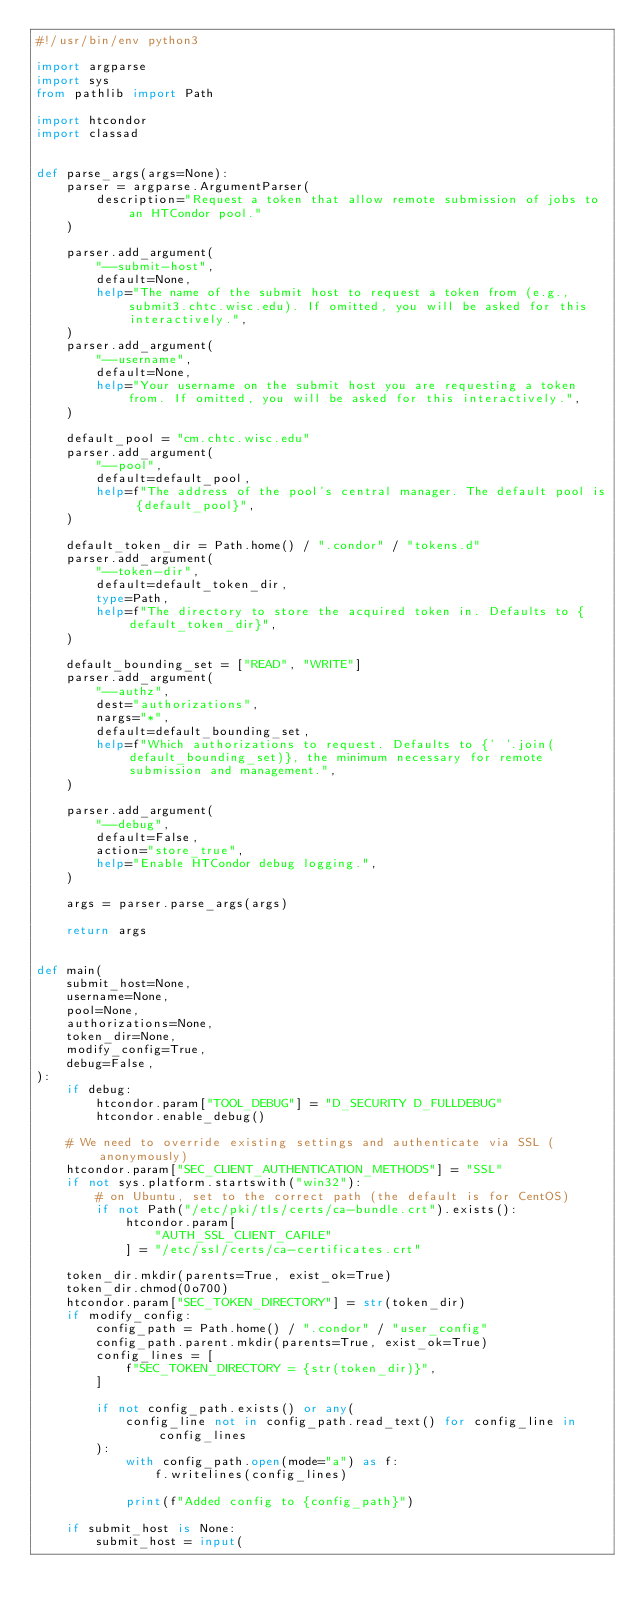Convert code to text. <code><loc_0><loc_0><loc_500><loc_500><_Python_>#!/usr/bin/env python3

import argparse
import sys
from pathlib import Path

import htcondor
import classad


def parse_args(args=None):
    parser = argparse.ArgumentParser(
        description="Request a token that allow remote submission of jobs to an HTCondor pool."
    )

    parser.add_argument(
        "--submit-host",
        default=None,
        help="The name of the submit host to request a token from (e.g., submit3.chtc.wisc.edu). If omitted, you will be asked for this interactively.",
    )
    parser.add_argument(
        "--username",
        default=None,
        help="Your username on the submit host you are requesting a token from. If omitted, you will be asked for this interactively.",
    )

    default_pool = "cm.chtc.wisc.edu"
    parser.add_argument(
        "--pool",
        default=default_pool,
        help=f"The address of the pool's central manager. The default pool is {default_pool}",
    )

    default_token_dir = Path.home() / ".condor" / "tokens.d"
    parser.add_argument(
        "--token-dir",
        default=default_token_dir,
        type=Path,
        help=f"The directory to store the acquired token in. Defaults to {default_token_dir}",
    )

    default_bounding_set = ["READ", "WRITE"]
    parser.add_argument(
        "--authz",
        dest="authorizations",
        nargs="*",
        default=default_bounding_set,
        help=f"Which authorizations to request. Defaults to {' '.join(default_bounding_set)}, the minimum necessary for remote submission and management.",
    )

    parser.add_argument(
        "--debug",
        default=False,
        action="store_true",
        help="Enable HTCondor debug logging.",
    )

    args = parser.parse_args(args)

    return args


def main(
    submit_host=None,
    username=None,
    pool=None,
    authorizations=None,
    token_dir=None,
    modify_config=True,
    debug=False,
):
    if debug:
        htcondor.param["TOOL_DEBUG"] = "D_SECURITY D_FULLDEBUG"
        htcondor.enable_debug()

    # We need to override existing settings and authenticate via SSL (anonymously)
    htcondor.param["SEC_CLIENT_AUTHENTICATION_METHODS"] = "SSL"
    if not sys.platform.startswith("win32"):
        # on Ubuntu, set to the correct path (the default is for CentOS)
        if not Path("/etc/pki/tls/certs/ca-bundle.crt").exists():
            htcondor.param[
                "AUTH_SSL_CLIENT_CAFILE"
            ] = "/etc/ssl/certs/ca-certificates.crt"

    token_dir.mkdir(parents=True, exist_ok=True)
    token_dir.chmod(0o700)
    htcondor.param["SEC_TOKEN_DIRECTORY"] = str(token_dir)
    if modify_config:
        config_path = Path.home() / ".condor" / "user_config"
        config_path.parent.mkdir(parents=True, exist_ok=True)
        config_lines = [
            f"SEC_TOKEN_DIRECTORY = {str(token_dir)}",
        ]

        if not config_path.exists() or any(
            config_line not in config_path.read_text() for config_line in config_lines
        ):
            with config_path.open(mode="a") as f:
                f.writelines(config_lines)

            print(f"Added config to {config_path}")

    if submit_host is None:
        submit_host = input(</code> 